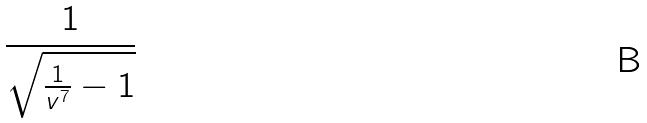<formula> <loc_0><loc_0><loc_500><loc_500>\frac { 1 } { \sqrt { \frac { 1 } { v ^ { 7 } } - 1 } }</formula> 